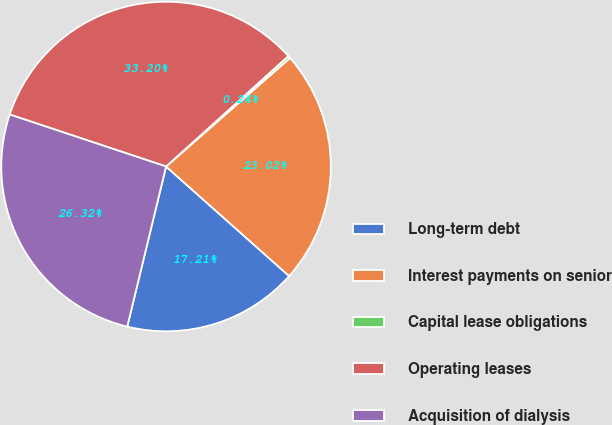<chart> <loc_0><loc_0><loc_500><loc_500><pie_chart><fcel>Long-term debt<fcel>Interest payments on senior<fcel>Capital lease obligations<fcel>Operating leases<fcel>Acquisition of dialysis<nl><fcel>17.21%<fcel>23.02%<fcel>0.24%<fcel>33.2%<fcel>26.32%<nl></chart> 